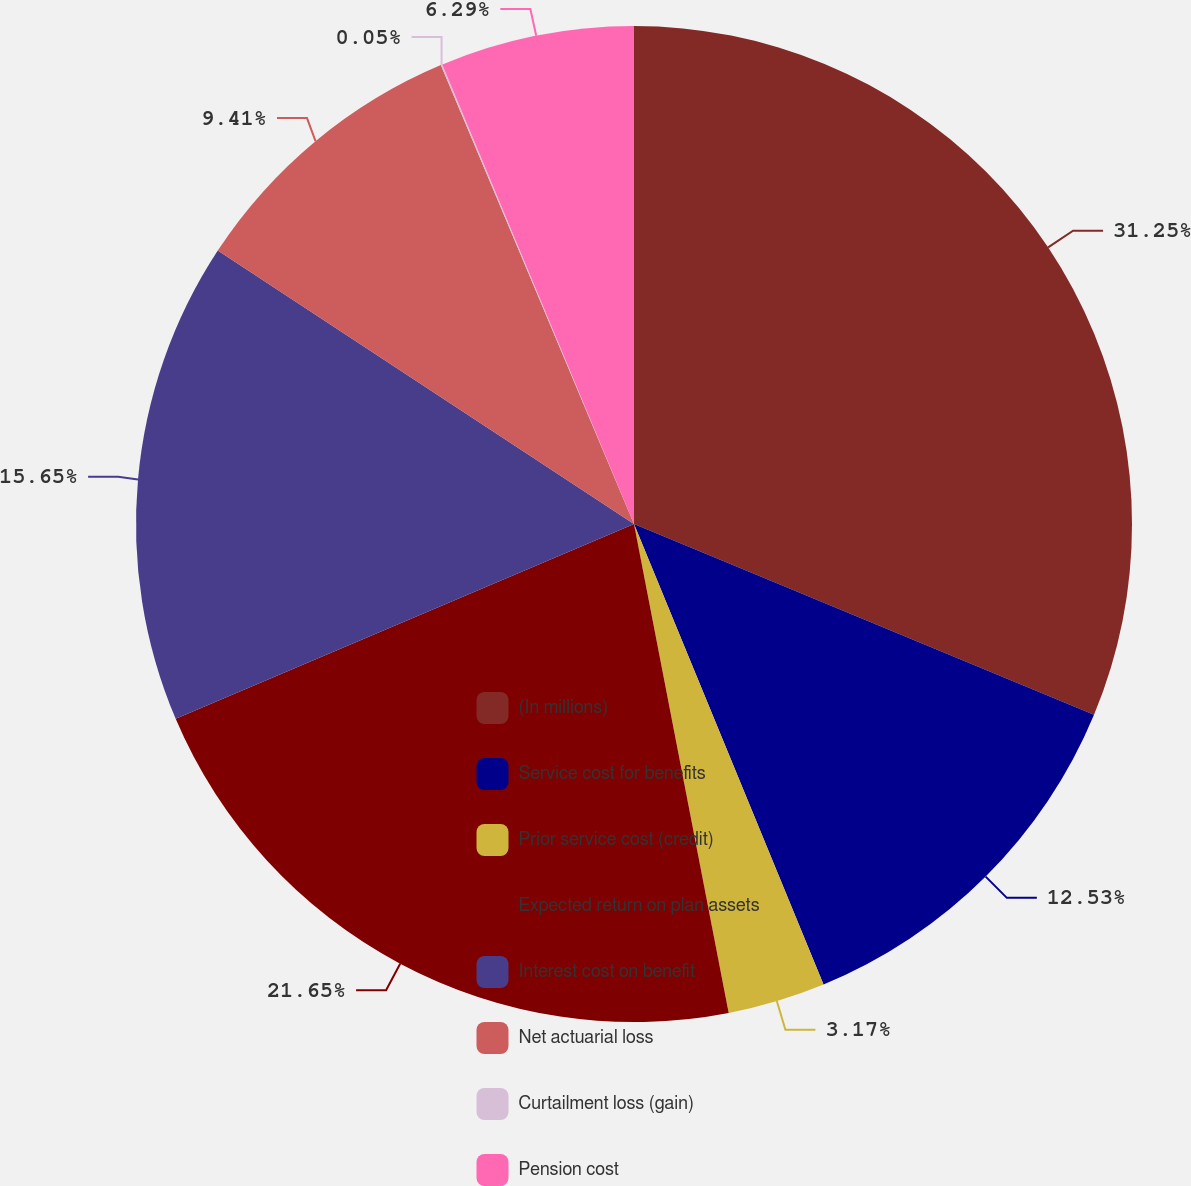Convert chart. <chart><loc_0><loc_0><loc_500><loc_500><pie_chart><fcel>(In millions)<fcel>Service cost for benefits<fcel>Prior service cost (credit)<fcel>Expected return on plan assets<fcel>Interest cost on benefit<fcel>Net actuarial loss<fcel>Curtailment loss (gain)<fcel>Pension cost<nl><fcel>31.26%<fcel>12.53%<fcel>3.17%<fcel>21.65%<fcel>15.65%<fcel>9.41%<fcel>0.05%<fcel>6.29%<nl></chart> 